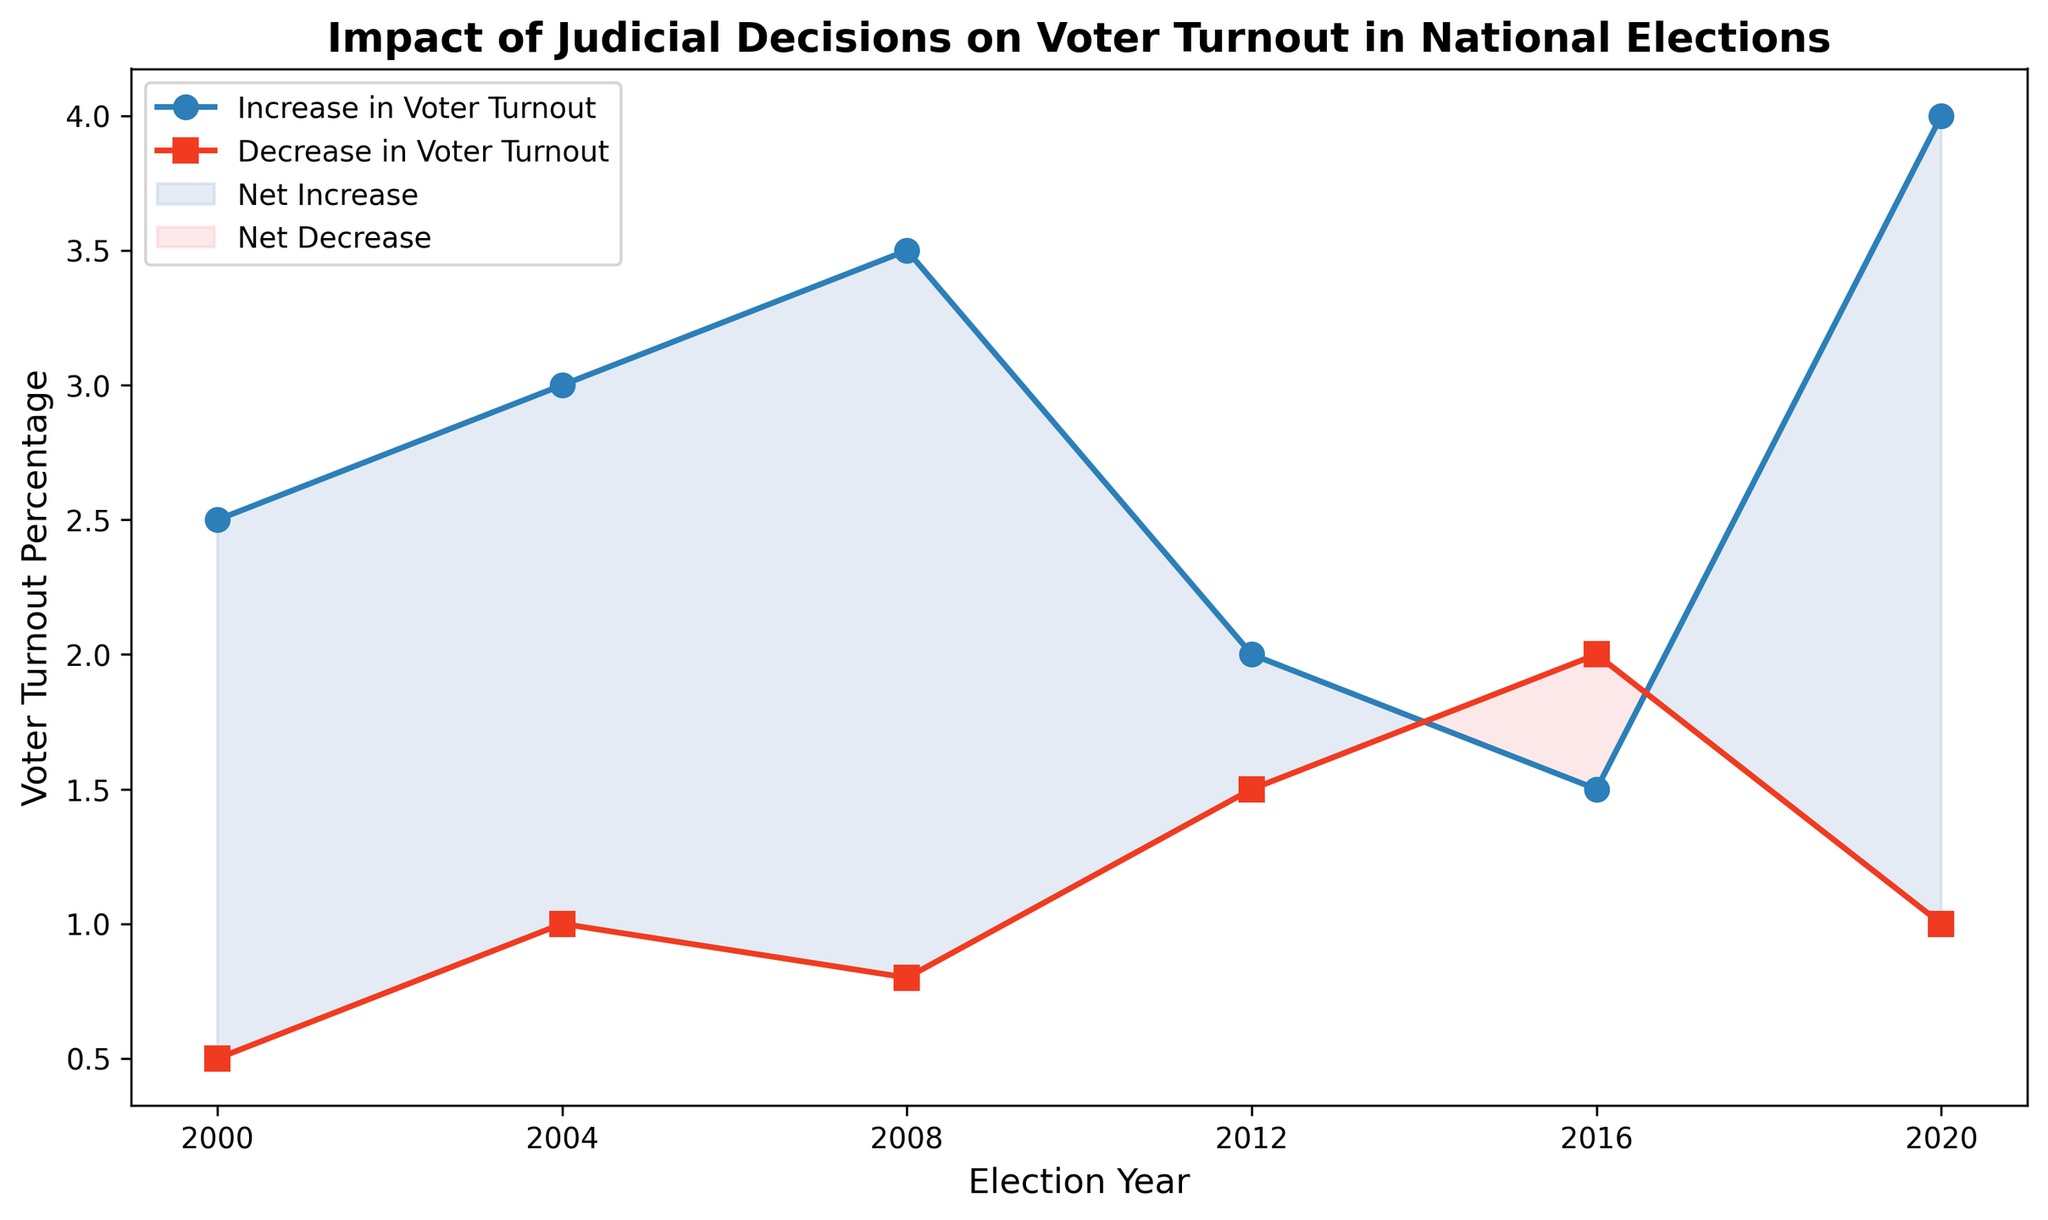What year saw the largest increase in voter turnout due to judicial decisions? To determine this, look at the blue line representing the increase in voter turnout percentage across different election years. The highest point on this line is in the year 2020.
Answer: 2020 In which year was the decrease in voter turnout percentage the highest? Look at the red line representing the decrease in voter turnout percentage. The highest point on this line is in the year 2016.
Answer: 2016 Between which years did the voter turnout see a net increase due to judicial decisions? Look at the blue filled area between the blue and red lines. Net increase occurred for the years in this filled area. These years are 2000, 2004, 2008, and 2020.
Answer: 2000, 2004, 2008, 2020 What is the net effect on voter turnout in 2016? Compare the increase and decrease in voter turnout for 2016. Increase is 1.5% and decrease is 2%. Since decrease is greater, it results in a net decrease.
Answer: Net decrease How did the net voter turnout change from 2008 to 2012? In 2008, the increase is 3.5% and the decrease is 0.8%, resulting in a net increase. In 2012, the increase is 2.0% and the decrease is 1.5%, also a net increase. The net increase from 2008 (2.7%) to 2012 (0.5%) decreases by 2.2%.
Answer: Decreased by 2.2% Which election year had the smallest net change in voter turnout due to judicial decisions? Look at the years where the smallest difference between the increase and decrease in voter turnout exist. In 2012, the net change is minimal at (2.0% increase - 1.5% decrease) = 0.5%.
Answer: 2012 In the election year 2004, how much higher is the increase in voter turnout than the decrease? For 2004, the increase is 3.0% and the decrease is 1.0%. The difference is 3.0% - 1.0% = 2.0%.
Answer: 2.0% What is the average increase in voter turnout across all years shown? Add all the percentages of increase: 2.5 + 3.0 + 3.5 + 2.0 + 1.5 + 4.0 = 16.5, then divide by the number of years: 16.5 / 6 ≈ 2.75%.
Answer: 2.75% Which year has the largest gap between increase and decrease in voter turnout? Look for the largest distance between the blue and red lines. In 2020, the increase is 4.0% and the decrease is 1.0%, resulting in a gap of 3.0%.
Answer: 2020 